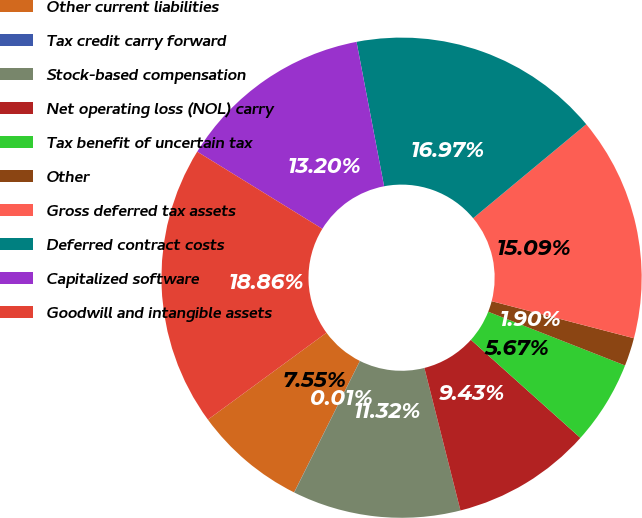Convert chart to OTSL. <chart><loc_0><loc_0><loc_500><loc_500><pie_chart><fcel>Other current liabilities<fcel>Tax credit carry forward<fcel>Stock-based compensation<fcel>Net operating loss (NOL) carry<fcel>Tax benefit of uncertain tax<fcel>Other<fcel>Gross deferred tax assets<fcel>Deferred contract costs<fcel>Capitalized software<fcel>Goodwill and intangible assets<nl><fcel>7.55%<fcel>0.01%<fcel>11.32%<fcel>9.43%<fcel>5.67%<fcel>1.9%<fcel>15.09%<fcel>16.97%<fcel>13.2%<fcel>18.86%<nl></chart> 